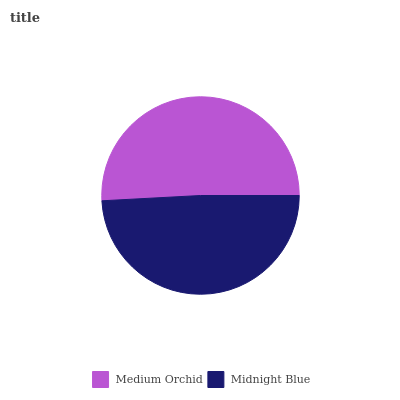Is Midnight Blue the minimum?
Answer yes or no. Yes. Is Medium Orchid the maximum?
Answer yes or no. Yes. Is Midnight Blue the maximum?
Answer yes or no. No. Is Medium Orchid greater than Midnight Blue?
Answer yes or no. Yes. Is Midnight Blue less than Medium Orchid?
Answer yes or no. Yes. Is Midnight Blue greater than Medium Orchid?
Answer yes or no. No. Is Medium Orchid less than Midnight Blue?
Answer yes or no. No. Is Medium Orchid the high median?
Answer yes or no. Yes. Is Midnight Blue the low median?
Answer yes or no. Yes. Is Midnight Blue the high median?
Answer yes or no. No. Is Medium Orchid the low median?
Answer yes or no. No. 